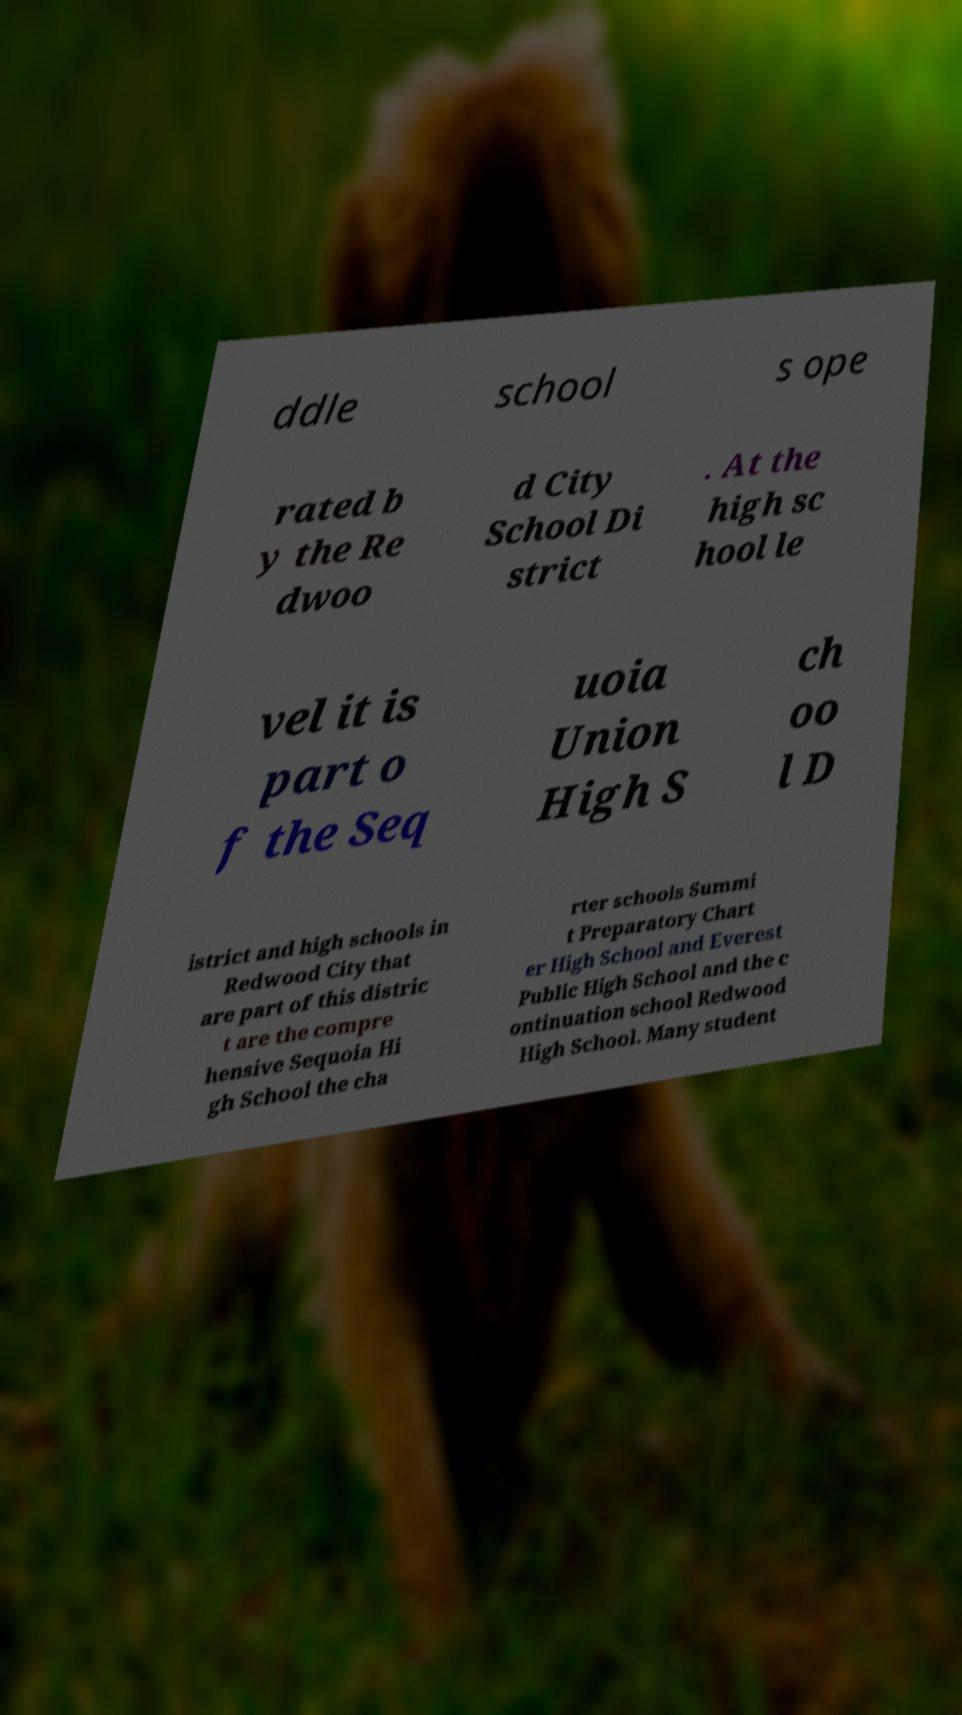Can you accurately transcribe the text from the provided image for me? ddle school s ope rated b y the Re dwoo d City School Di strict . At the high sc hool le vel it is part o f the Seq uoia Union High S ch oo l D istrict and high schools in Redwood City that are part of this distric t are the compre hensive Sequoia Hi gh School the cha rter schools Summi t Preparatory Chart er High School and Everest Public High School and the c ontinuation school Redwood High School. Many student 